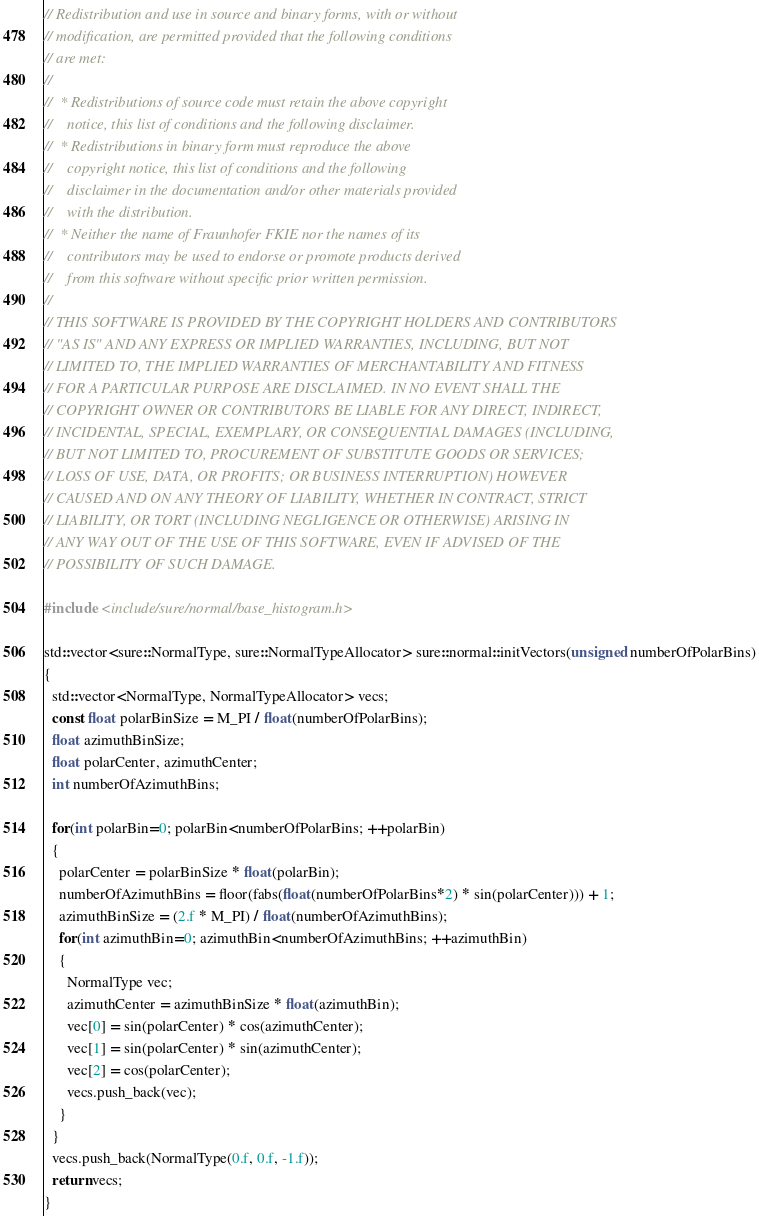<code> <loc_0><loc_0><loc_500><loc_500><_C++_>// Redistribution and use in source and binary forms, with or without
// modification, are permitted provided that the following conditions
// are met:
//
//  * Redistributions of source code must retain the above copyright
//    notice, this list of conditions and the following disclaimer.
//  * Redistributions in binary form must reproduce the above
//    copyright notice, this list of conditions and the following
//    disclaimer in the documentation and/or other materials provided
//    with the distribution.
//  * Neither the name of Fraunhofer FKIE nor the names of its
//    contributors may be used to endorse or promote products derived
//    from this software without specific prior written permission.
//
// THIS SOFTWARE IS PROVIDED BY THE COPYRIGHT HOLDERS AND CONTRIBUTORS
// "AS IS" AND ANY EXPRESS OR IMPLIED WARRANTIES, INCLUDING, BUT NOT
// LIMITED TO, THE IMPLIED WARRANTIES OF MERCHANTABILITY AND FITNESS
// FOR A PARTICULAR PURPOSE ARE DISCLAIMED. IN NO EVENT SHALL THE
// COPYRIGHT OWNER OR CONTRIBUTORS BE LIABLE FOR ANY DIRECT, INDIRECT,
// INCIDENTAL, SPECIAL, EXEMPLARY, OR CONSEQUENTIAL DAMAGES (INCLUDING,
// BUT NOT LIMITED TO, PROCUREMENT OF SUBSTITUTE GOODS OR SERVICES;
// LOSS OF USE, DATA, OR PROFITS; OR BUSINESS INTERRUPTION) HOWEVER
// CAUSED AND ON ANY THEORY OF LIABILITY, WHETHER IN CONTRACT, STRICT
// LIABILITY, OR TORT (INCLUDING NEGLIGENCE OR OTHERWISE) ARISING IN
// ANY WAY OUT OF THE USE OF THIS SOFTWARE, EVEN IF ADVISED OF THE
// POSSIBILITY OF SUCH DAMAGE.

#include <include/sure/normal/base_histogram.h>

std::vector<sure::NormalType, sure::NormalTypeAllocator> sure::normal::initVectors(unsigned numberOfPolarBins)
{
  std::vector<NormalType, NormalTypeAllocator> vecs;
  const float polarBinSize = M_PI / float(numberOfPolarBins);
  float azimuthBinSize;
  float polarCenter, azimuthCenter;
  int numberOfAzimuthBins;

  for(int polarBin=0; polarBin<numberOfPolarBins; ++polarBin)
  {
    polarCenter = polarBinSize * float(polarBin);
    numberOfAzimuthBins = floor(fabs(float(numberOfPolarBins*2) * sin(polarCenter))) + 1;
    azimuthBinSize = (2.f * M_PI) / float(numberOfAzimuthBins);
    for(int azimuthBin=0; azimuthBin<numberOfAzimuthBins; ++azimuthBin)
    {
      NormalType vec;
      azimuthCenter = azimuthBinSize * float(azimuthBin);
      vec[0] = sin(polarCenter) * cos(azimuthCenter);
      vec[1] = sin(polarCenter) * sin(azimuthCenter);
      vec[2] = cos(polarCenter);
      vecs.push_back(vec);
    }
  }
  vecs.push_back(NormalType(0.f, 0.f, -1.f));
  return vecs;
}

</code> 